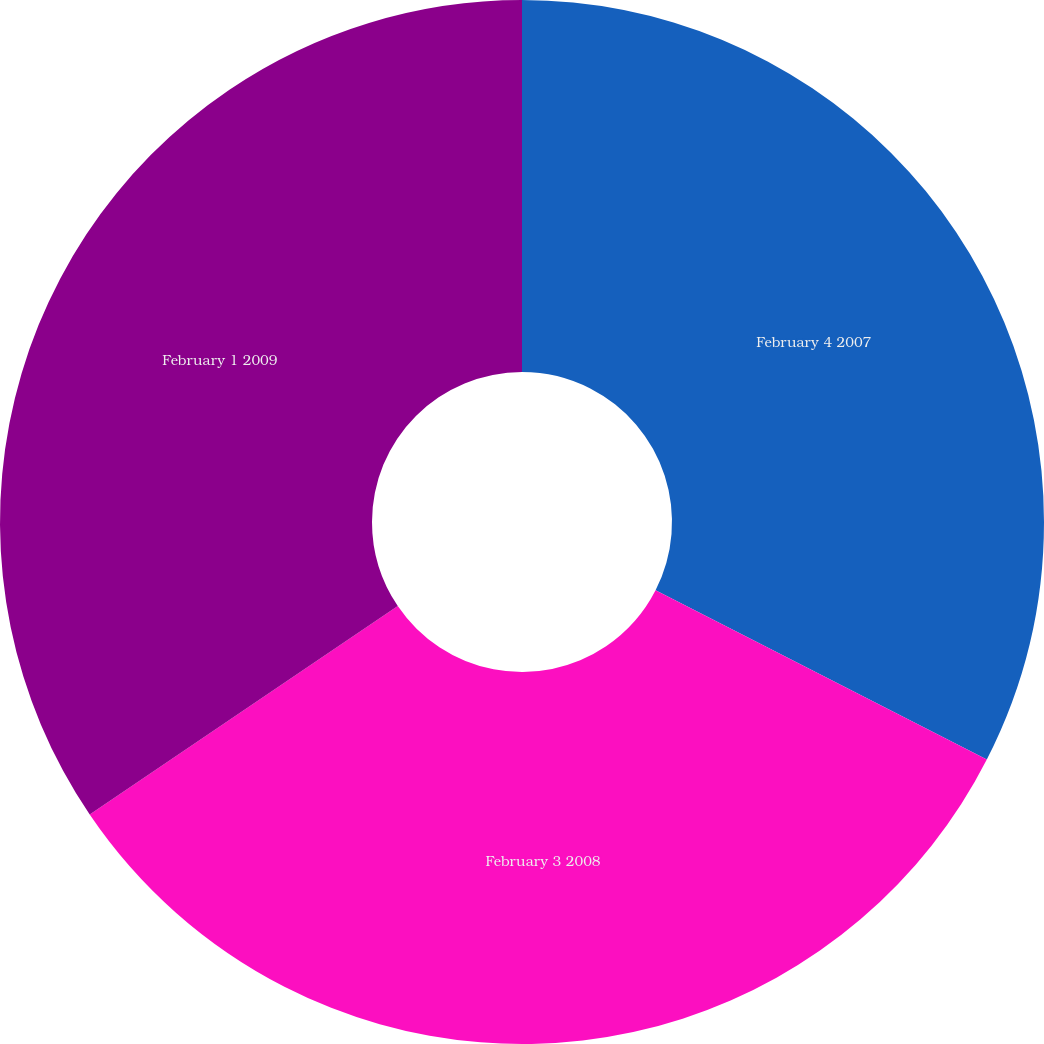Convert chart. <chart><loc_0><loc_0><loc_500><loc_500><pie_chart><fcel>February 4 2007<fcel>February 3 2008<fcel>February 1 2009<nl><fcel>32.52%<fcel>33.01%<fcel>34.47%<nl></chart> 